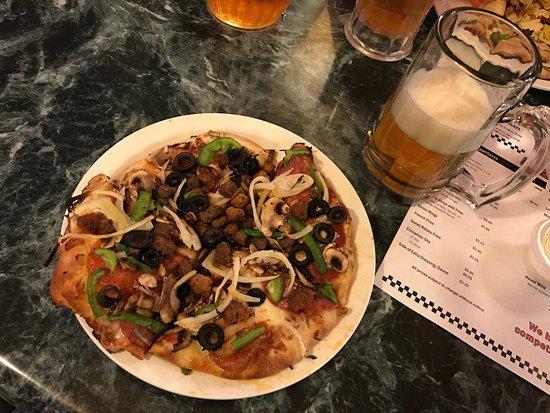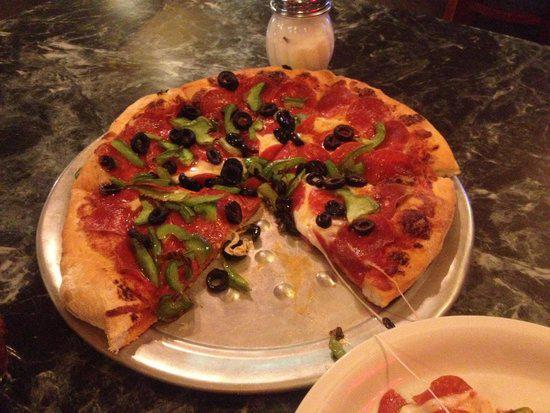The first image is the image on the left, the second image is the image on the right. Evaluate the accuracy of this statement regarding the images: "One image shows a pizza in an open box and includes at least two condiment containers in the image.". Is it true? Answer yes or no. No. The first image is the image on the left, the second image is the image on the right. Assess this claim about the two images: "There are two complete pizzas.". Correct or not? Answer yes or no. No. 